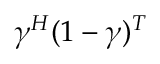Convert formula to latex. <formula><loc_0><loc_0><loc_500><loc_500>\gamma ^ { H } ( 1 - \gamma ) ^ { T }</formula> 